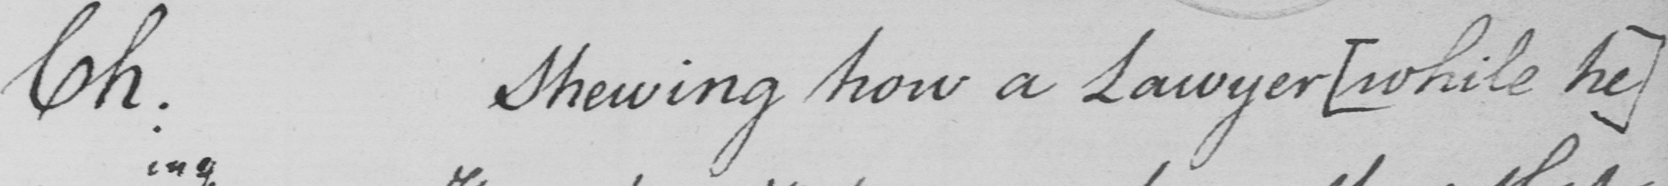What is written in this line of handwriting? Ch . Shewing how a Lawyer  [ while he ] 